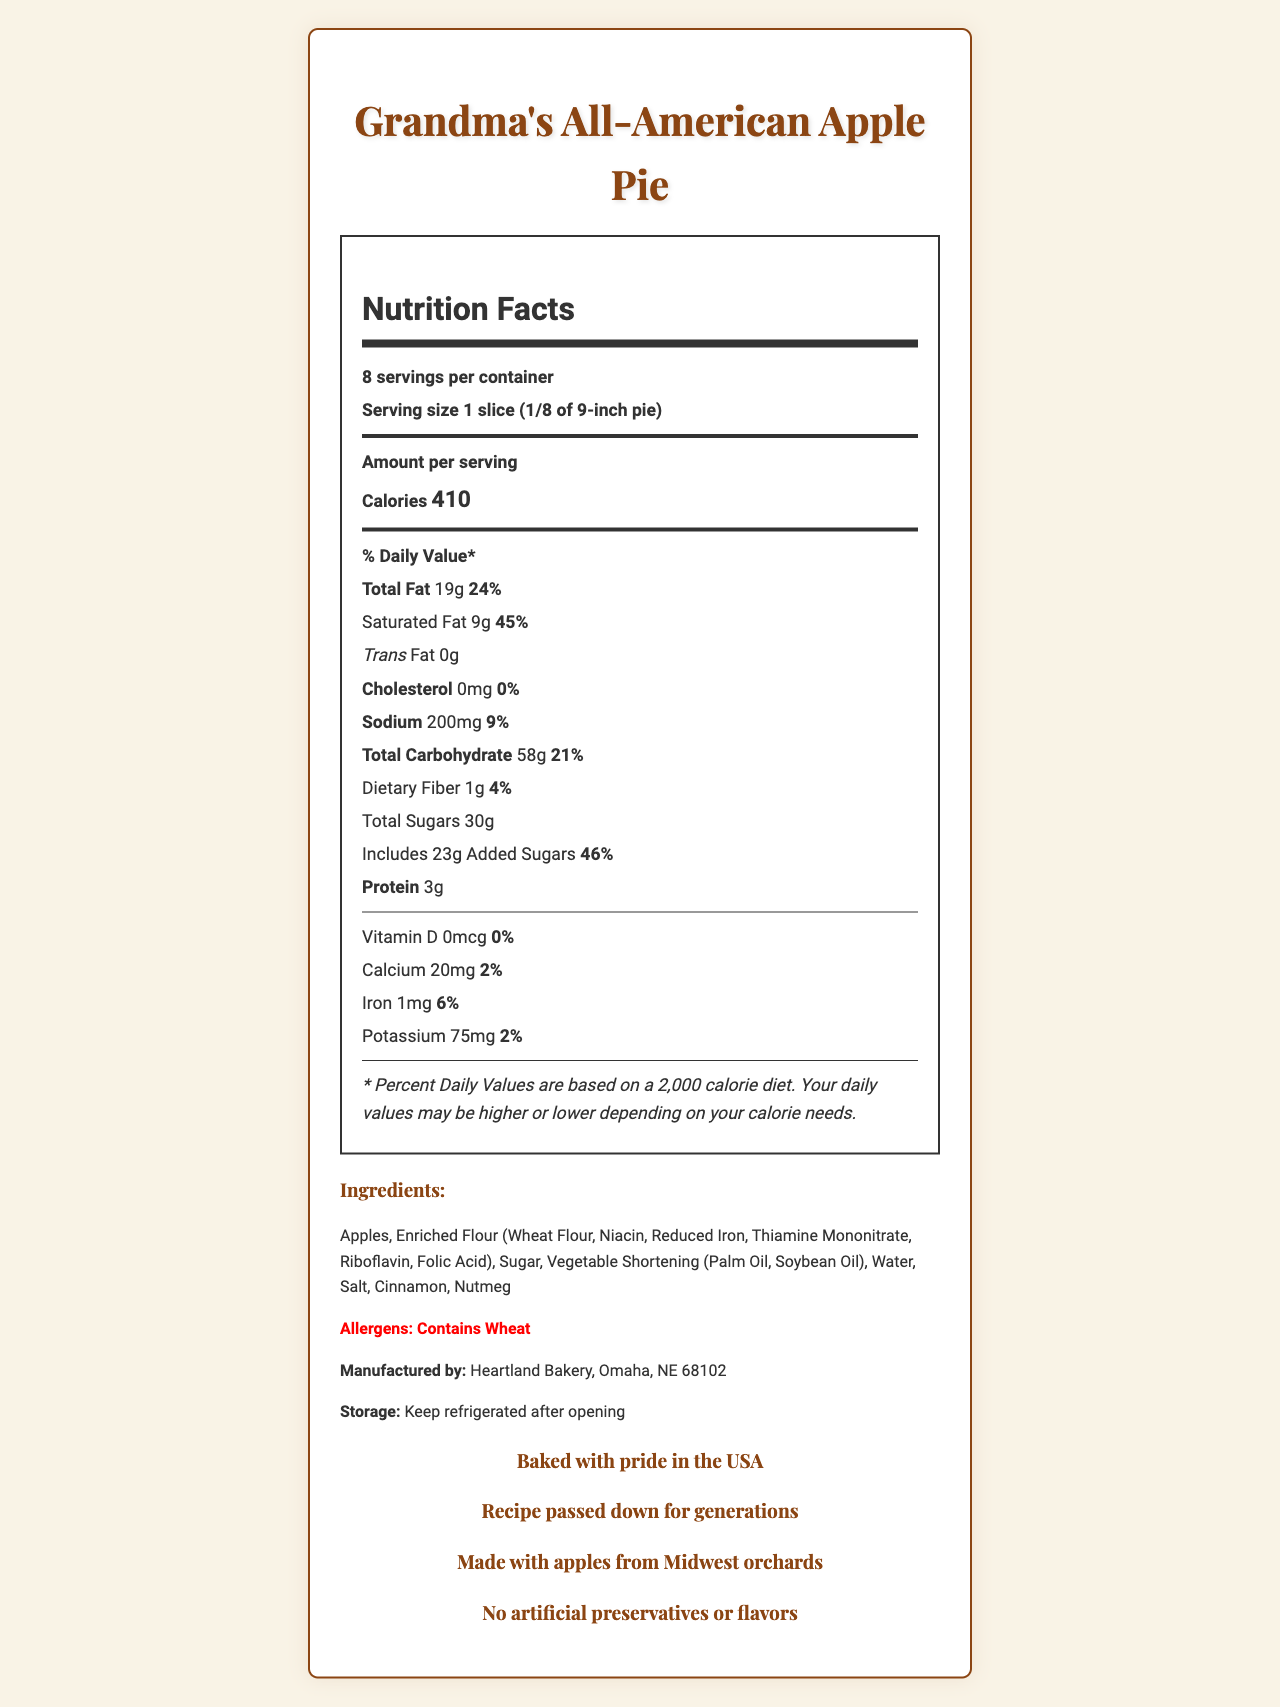what is the serving size for Grandma's All-American Apple Pie? The serving size is specified in the document as "1 slice (1/8 of 9-inch pie).”
Answer: 1 slice (1/8 of 9-inch pie) how many calories are in one slice of this apple pie? The document states that each serving contains 410 calories.
Answer: 410 calories how much total sugar is in one serving of the apple pie? The nutrition label indicates that each serving has a total of 30 grams of sugar.
Answer: 30 grams what is the daily value percentage for added sugars in one serving? The daily value for added sugars is 46%, as stated in the nutrition label.
Answer: 46% how many grams of protein are in one serving? The document lists 3 grams of protein per serving.
Answer: 3 grams which of the following is a main ingredient? A. Bananas B. Chocolate C. Apples D. Almonds The ingredient list includes "Apples," making them a main ingredient in Grandma's All-American Apple Pie.
Answer: C. Apples what percentage of the daily value does the sodium in one serving of apple pie represent? The nutrition label states that the sodium content represents 9% of the daily value.
Answer: 9% is there any cholesterol in one serving of the apple pie? The document mentions that the cholesterol amount is 0 mg, meaning there is no cholesterol in one serving.
Answer: No does the nutritional label specify the amount of vitamin C in one serving? The document does not mention vitamin C in the nutrition label.
Answer: No who manufactures Grandma's All-American Apple Pie? The manufacturer is listed as "Heartland Bakery, Omaha, NE 68102."
Answer: Heartland Bakery, Omaha, NE 68102 how should the pie be stored after opening? The storage instructions indicate that the pie should be refrigerated after opening.
Answer: Keep refrigerated after opening summary of the document The document aims to give consumers comprehensive nutritional information and additional context about the product's quality and origin.
Answer: The document provides a detailed nutrition facts label for Grandma's All-American Apple Pie. It includes serving size, calorie content, amounts of various nutrients per serving, ingredient list, allergen information, manufacturer details, storage instructions, and some additional messages like the pie being baked with pride in the USA, family tradition, and local sourcing. 